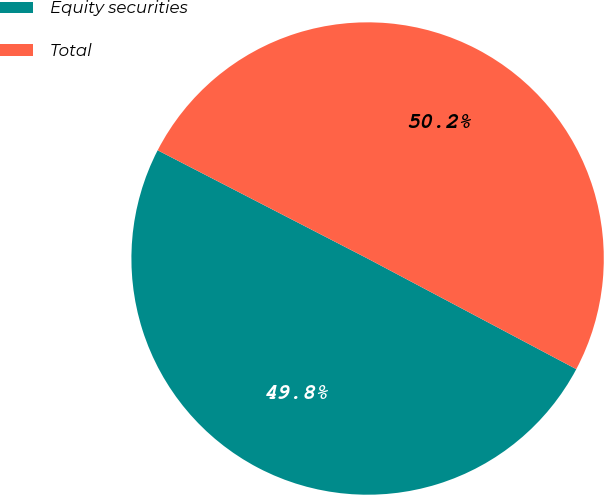Convert chart. <chart><loc_0><loc_0><loc_500><loc_500><pie_chart><fcel>Equity securities<fcel>Total<nl><fcel>49.82%<fcel>50.18%<nl></chart> 